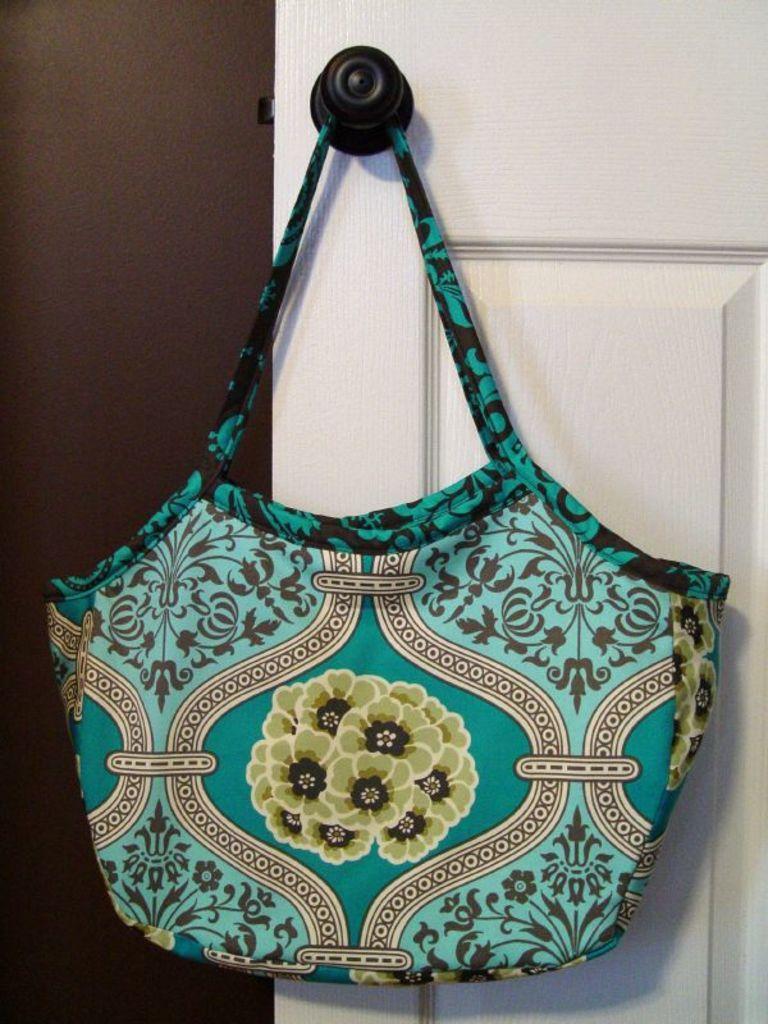Can you describe this image briefly? In this picture the there is a handbag and a door with a handle and there is a wall on to the left. 